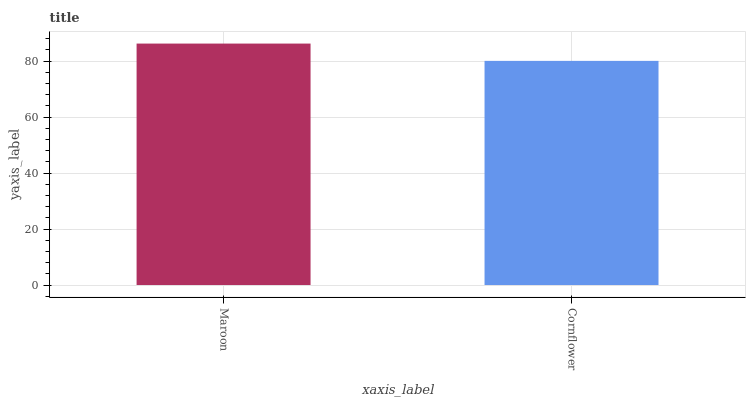Is Cornflower the minimum?
Answer yes or no. Yes. Is Maroon the maximum?
Answer yes or no. Yes. Is Cornflower the maximum?
Answer yes or no. No. Is Maroon greater than Cornflower?
Answer yes or no. Yes. Is Cornflower less than Maroon?
Answer yes or no. Yes. Is Cornflower greater than Maroon?
Answer yes or no. No. Is Maroon less than Cornflower?
Answer yes or no. No. Is Maroon the high median?
Answer yes or no. Yes. Is Cornflower the low median?
Answer yes or no. Yes. Is Cornflower the high median?
Answer yes or no. No. Is Maroon the low median?
Answer yes or no. No. 